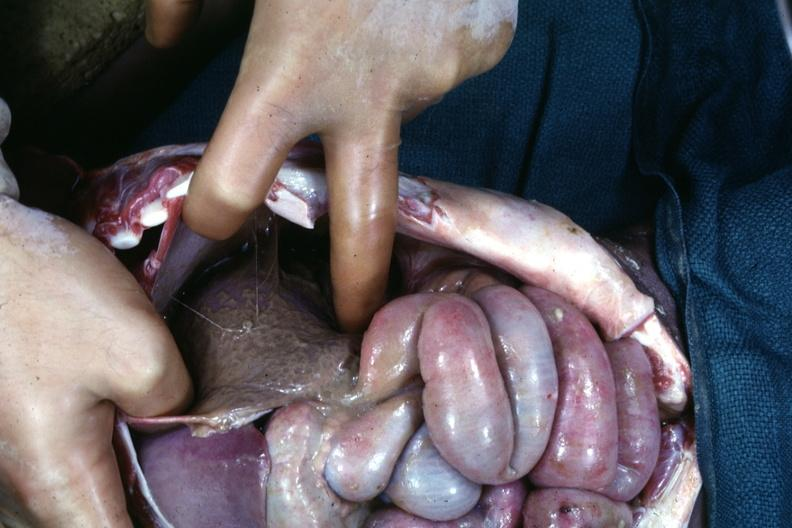what does an opened peritoneal cavity cause by fibrous band strangulation see?
Answer the question using a single word or phrase. Other slides 